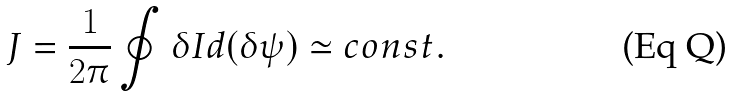Convert formula to latex. <formula><loc_0><loc_0><loc_500><loc_500>J = \frac { 1 } { 2 \pi } \oint \delta I d ( \delta \psi ) \simeq c o n s t .</formula> 